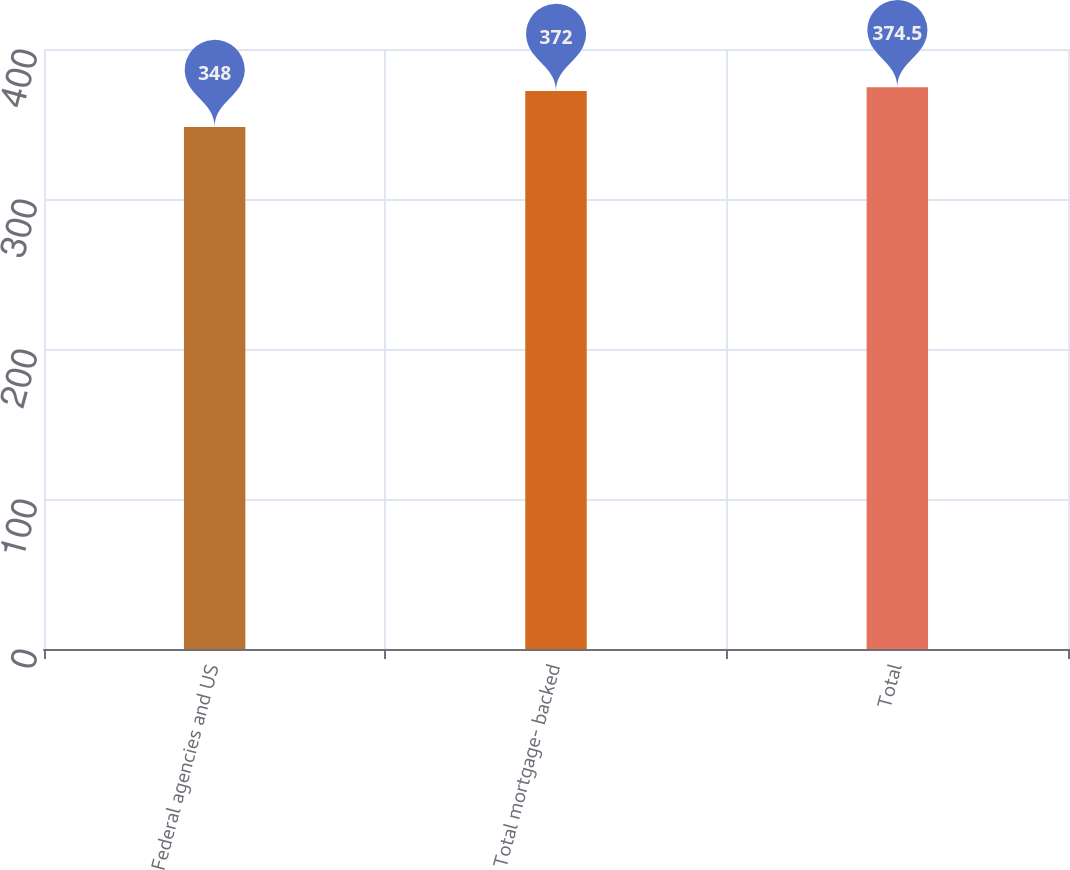Convert chart to OTSL. <chart><loc_0><loc_0><loc_500><loc_500><bar_chart><fcel>Federal agencies and US<fcel>Total mortgage- backed<fcel>Total<nl><fcel>348<fcel>372<fcel>374.5<nl></chart> 